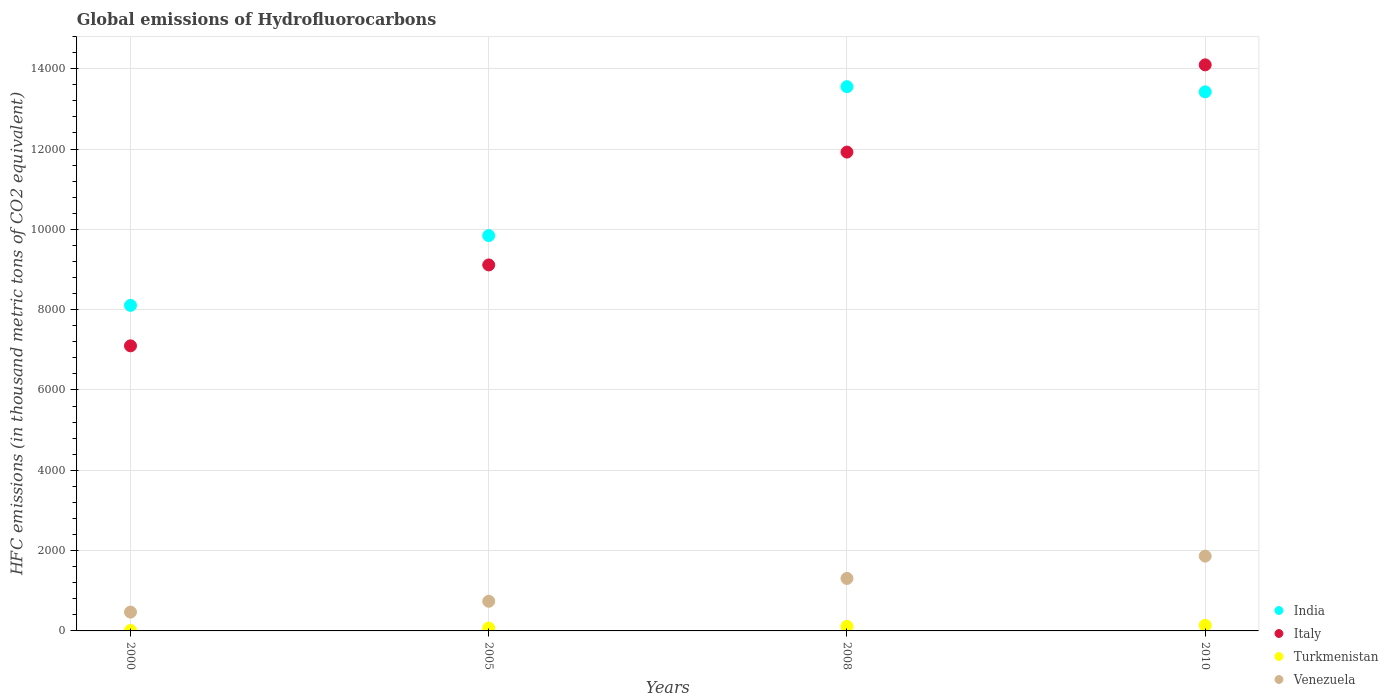How many different coloured dotlines are there?
Provide a short and direct response. 4. Is the number of dotlines equal to the number of legend labels?
Your response must be concise. Yes. What is the global emissions of Hydrofluorocarbons in Italy in 2005?
Offer a terse response. 9114.5. Across all years, what is the maximum global emissions of Hydrofluorocarbons in Turkmenistan?
Provide a short and direct response. 139. Across all years, what is the minimum global emissions of Hydrofluorocarbons in India?
Make the answer very short. 8107.2. What is the total global emissions of Hydrofluorocarbons in Turkmenistan in the graph?
Provide a succinct answer. 335. What is the difference between the global emissions of Hydrofluorocarbons in Venezuela in 2000 and that in 2008?
Offer a very short reply. -838.6. What is the difference between the global emissions of Hydrofluorocarbons in Italy in 2000 and the global emissions of Hydrofluorocarbons in Venezuela in 2008?
Provide a short and direct response. 5792.4. What is the average global emissions of Hydrofluorocarbons in Turkmenistan per year?
Your answer should be very brief. 83.75. In the year 2005, what is the difference between the global emissions of Hydrofluorocarbons in India and global emissions of Hydrofluorocarbons in Turkmenistan?
Offer a terse response. 9772.3. What is the ratio of the global emissions of Hydrofluorocarbons in Italy in 2005 to that in 2010?
Offer a very short reply. 0.65. Is the global emissions of Hydrofluorocarbons in Italy in 2005 less than that in 2010?
Your answer should be very brief. Yes. What is the difference between the highest and the second highest global emissions of Hydrofluorocarbons in Italy?
Give a very brief answer. 2172.5. What is the difference between the highest and the lowest global emissions of Hydrofluorocarbons in Venezuela?
Your response must be concise. 1394.5. Is it the case that in every year, the sum of the global emissions of Hydrofluorocarbons in Venezuela and global emissions of Hydrofluorocarbons in India  is greater than the sum of global emissions of Hydrofluorocarbons in Turkmenistan and global emissions of Hydrofluorocarbons in Italy?
Make the answer very short. Yes. Does the global emissions of Hydrofluorocarbons in Turkmenistan monotonically increase over the years?
Your response must be concise. Yes. How many dotlines are there?
Keep it short and to the point. 4. How many years are there in the graph?
Ensure brevity in your answer.  4. What is the difference between two consecutive major ticks on the Y-axis?
Offer a very short reply. 2000. Are the values on the major ticks of Y-axis written in scientific E-notation?
Keep it short and to the point. No. Does the graph contain any zero values?
Provide a succinct answer. No. Does the graph contain grids?
Your answer should be compact. Yes. How many legend labels are there?
Make the answer very short. 4. What is the title of the graph?
Give a very brief answer. Global emissions of Hydrofluorocarbons. What is the label or title of the X-axis?
Offer a very short reply. Years. What is the label or title of the Y-axis?
Give a very brief answer. HFC emissions (in thousand metric tons of CO2 equivalent). What is the HFC emissions (in thousand metric tons of CO2 equivalent) of India in 2000?
Offer a terse response. 8107.2. What is the HFC emissions (in thousand metric tons of CO2 equivalent) in Italy in 2000?
Provide a short and direct response. 7099.5. What is the HFC emissions (in thousand metric tons of CO2 equivalent) in Turkmenistan in 2000?
Make the answer very short. 10.9. What is the HFC emissions (in thousand metric tons of CO2 equivalent) of Venezuela in 2000?
Ensure brevity in your answer.  468.5. What is the HFC emissions (in thousand metric tons of CO2 equivalent) of India in 2005?
Offer a very short reply. 9845.2. What is the HFC emissions (in thousand metric tons of CO2 equivalent) of Italy in 2005?
Provide a succinct answer. 9114.5. What is the HFC emissions (in thousand metric tons of CO2 equivalent) of Turkmenistan in 2005?
Give a very brief answer. 72.9. What is the HFC emissions (in thousand metric tons of CO2 equivalent) in Venezuela in 2005?
Keep it short and to the point. 738.4. What is the HFC emissions (in thousand metric tons of CO2 equivalent) of India in 2008?
Provide a succinct answer. 1.36e+04. What is the HFC emissions (in thousand metric tons of CO2 equivalent) in Italy in 2008?
Keep it short and to the point. 1.19e+04. What is the HFC emissions (in thousand metric tons of CO2 equivalent) in Turkmenistan in 2008?
Give a very brief answer. 112.2. What is the HFC emissions (in thousand metric tons of CO2 equivalent) of Venezuela in 2008?
Your answer should be very brief. 1307.1. What is the HFC emissions (in thousand metric tons of CO2 equivalent) of India in 2010?
Your answer should be very brief. 1.34e+04. What is the HFC emissions (in thousand metric tons of CO2 equivalent) in Italy in 2010?
Make the answer very short. 1.41e+04. What is the HFC emissions (in thousand metric tons of CO2 equivalent) in Turkmenistan in 2010?
Ensure brevity in your answer.  139. What is the HFC emissions (in thousand metric tons of CO2 equivalent) of Venezuela in 2010?
Give a very brief answer. 1863. Across all years, what is the maximum HFC emissions (in thousand metric tons of CO2 equivalent) in India?
Ensure brevity in your answer.  1.36e+04. Across all years, what is the maximum HFC emissions (in thousand metric tons of CO2 equivalent) in Italy?
Provide a succinct answer. 1.41e+04. Across all years, what is the maximum HFC emissions (in thousand metric tons of CO2 equivalent) in Turkmenistan?
Ensure brevity in your answer.  139. Across all years, what is the maximum HFC emissions (in thousand metric tons of CO2 equivalent) of Venezuela?
Offer a terse response. 1863. Across all years, what is the minimum HFC emissions (in thousand metric tons of CO2 equivalent) of India?
Offer a terse response. 8107.2. Across all years, what is the minimum HFC emissions (in thousand metric tons of CO2 equivalent) in Italy?
Make the answer very short. 7099.5. Across all years, what is the minimum HFC emissions (in thousand metric tons of CO2 equivalent) of Turkmenistan?
Ensure brevity in your answer.  10.9. Across all years, what is the minimum HFC emissions (in thousand metric tons of CO2 equivalent) in Venezuela?
Your answer should be compact. 468.5. What is the total HFC emissions (in thousand metric tons of CO2 equivalent) of India in the graph?
Your answer should be very brief. 4.49e+04. What is the total HFC emissions (in thousand metric tons of CO2 equivalent) of Italy in the graph?
Offer a very short reply. 4.22e+04. What is the total HFC emissions (in thousand metric tons of CO2 equivalent) in Turkmenistan in the graph?
Give a very brief answer. 335. What is the total HFC emissions (in thousand metric tons of CO2 equivalent) in Venezuela in the graph?
Provide a succinct answer. 4377. What is the difference between the HFC emissions (in thousand metric tons of CO2 equivalent) of India in 2000 and that in 2005?
Offer a terse response. -1738. What is the difference between the HFC emissions (in thousand metric tons of CO2 equivalent) of Italy in 2000 and that in 2005?
Your answer should be compact. -2015. What is the difference between the HFC emissions (in thousand metric tons of CO2 equivalent) of Turkmenistan in 2000 and that in 2005?
Your answer should be compact. -62. What is the difference between the HFC emissions (in thousand metric tons of CO2 equivalent) in Venezuela in 2000 and that in 2005?
Make the answer very short. -269.9. What is the difference between the HFC emissions (in thousand metric tons of CO2 equivalent) in India in 2000 and that in 2008?
Provide a succinct answer. -5446.5. What is the difference between the HFC emissions (in thousand metric tons of CO2 equivalent) of Italy in 2000 and that in 2008?
Offer a very short reply. -4825. What is the difference between the HFC emissions (in thousand metric tons of CO2 equivalent) in Turkmenistan in 2000 and that in 2008?
Give a very brief answer. -101.3. What is the difference between the HFC emissions (in thousand metric tons of CO2 equivalent) in Venezuela in 2000 and that in 2008?
Offer a terse response. -838.6. What is the difference between the HFC emissions (in thousand metric tons of CO2 equivalent) in India in 2000 and that in 2010?
Provide a succinct answer. -5317.8. What is the difference between the HFC emissions (in thousand metric tons of CO2 equivalent) in Italy in 2000 and that in 2010?
Your answer should be compact. -6997.5. What is the difference between the HFC emissions (in thousand metric tons of CO2 equivalent) of Turkmenistan in 2000 and that in 2010?
Your answer should be compact. -128.1. What is the difference between the HFC emissions (in thousand metric tons of CO2 equivalent) in Venezuela in 2000 and that in 2010?
Provide a succinct answer. -1394.5. What is the difference between the HFC emissions (in thousand metric tons of CO2 equivalent) in India in 2005 and that in 2008?
Your response must be concise. -3708.5. What is the difference between the HFC emissions (in thousand metric tons of CO2 equivalent) in Italy in 2005 and that in 2008?
Offer a terse response. -2810. What is the difference between the HFC emissions (in thousand metric tons of CO2 equivalent) in Turkmenistan in 2005 and that in 2008?
Keep it short and to the point. -39.3. What is the difference between the HFC emissions (in thousand metric tons of CO2 equivalent) in Venezuela in 2005 and that in 2008?
Offer a terse response. -568.7. What is the difference between the HFC emissions (in thousand metric tons of CO2 equivalent) of India in 2005 and that in 2010?
Keep it short and to the point. -3579.8. What is the difference between the HFC emissions (in thousand metric tons of CO2 equivalent) in Italy in 2005 and that in 2010?
Provide a succinct answer. -4982.5. What is the difference between the HFC emissions (in thousand metric tons of CO2 equivalent) of Turkmenistan in 2005 and that in 2010?
Your answer should be compact. -66.1. What is the difference between the HFC emissions (in thousand metric tons of CO2 equivalent) of Venezuela in 2005 and that in 2010?
Provide a short and direct response. -1124.6. What is the difference between the HFC emissions (in thousand metric tons of CO2 equivalent) of India in 2008 and that in 2010?
Provide a succinct answer. 128.7. What is the difference between the HFC emissions (in thousand metric tons of CO2 equivalent) of Italy in 2008 and that in 2010?
Offer a very short reply. -2172.5. What is the difference between the HFC emissions (in thousand metric tons of CO2 equivalent) of Turkmenistan in 2008 and that in 2010?
Make the answer very short. -26.8. What is the difference between the HFC emissions (in thousand metric tons of CO2 equivalent) of Venezuela in 2008 and that in 2010?
Ensure brevity in your answer.  -555.9. What is the difference between the HFC emissions (in thousand metric tons of CO2 equivalent) of India in 2000 and the HFC emissions (in thousand metric tons of CO2 equivalent) of Italy in 2005?
Your answer should be compact. -1007.3. What is the difference between the HFC emissions (in thousand metric tons of CO2 equivalent) in India in 2000 and the HFC emissions (in thousand metric tons of CO2 equivalent) in Turkmenistan in 2005?
Make the answer very short. 8034.3. What is the difference between the HFC emissions (in thousand metric tons of CO2 equivalent) in India in 2000 and the HFC emissions (in thousand metric tons of CO2 equivalent) in Venezuela in 2005?
Keep it short and to the point. 7368.8. What is the difference between the HFC emissions (in thousand metric tons of CO2 equivalent) in Italy in 2000 and the HFC emissions (in thousand metric tons of CO2 equivalent) in Turkmenistan in 2005?
Offer a very short reply. 7026.6. What is the difference between the HFC emissions (in thousand metric tons of CO2 equivalent) in Italy in 2000 and the HFC emissions (in thousand metric tons of CO2 equivalent) in Venezuela in 2005?
Keep it short and to the point. 6361.1. What is the difference between the HFC emissions (in thousand metric tons of CO2 equivalent) in Turkmenistan in 2000 and the HFC emissions (in thousand metric tons of CO2 equivalent) in Venezuela in 2005?
Provide a succinct answer. -727.5. What is the difference between the HFC emissions (in thousand metric tons of CO2 equivalent) of India in 2000 and the HFC emissions (in thousand metric tons of CO2 equivalent) of Italy in 2008?
Your answer should be compact. -3817.3. What is the difference between the HFC emissions (in thousand metric tons of CO2 equivalent) of India in 2000 and the HFC emissions (in thousand metric tons of CO2 equivalent) of Turkmenistan in 2008?
Ensure brevity in your answer.  7995. What is the difference between the HFC emissions (in thousand metric tons of CO2 equivalent) in India in 2000 and the HFC emissions (in thousand metric tons of CO2 equivalent) in Venezuela in 2008?
Provide a succinct answer. 6800.1. What is the difference between the HFC emissions (in thousand metric tons of CO2 equivalent) in Italy in 2000 and the HFC emissions (in thousand metric tons of CO2 equivalent) in Turkmenistan in 2008?
Provide a short and direct response. 6987.3. What is the difference between the HFC emissions (in thousand metric tons of CO2 equivalent) in Italy in 2000 and the HFC emissions (in thousand metric tons of CO2 equivalent) in Venezuela in 2008?
Your response must be concise. 5792.4. What is the difference between the HFC emissions (in thousand metric tons of CO2 equivalent) of Turkmenistan in 2000 and the HFC emissions (in thousand metric tons of CO2 equivalent) of Venezuela in 2008?
Keep it short and to the point. -1296.2. What is the difference between the HFC emissions (in thousand metric tons of CO2 equivalent) in India in 2000 and the HFC emissions (in thousand metric tons of CO2 equivalent) in Italy in 2010?
Offer a terse response. -5989.8. What is the difference between the HFC emissions (in thousand metric tons of CO2 equivalent) in India in 2000 and the HFC emissions (in thousand metric tons of CO2 equivalent) in Turkmenistan in 2010?
Your response must be concise. 7968.2. What is the difference between the HFC emissions (in thousand metric tons of CO2 equivalent) in India in 2000 and the HFC emissions (in thousand metric tons of CO2 equivalent) in Venezuela in 2010?
Give a very brief answer. 6244.2. What is the difference between the HFC emissions (in thousand metric tons of CO2 equivalent) of Italy in 2000 and the HFC emissions (in thousand metric tons of CO2 equivalent) of Turkmenistan in 2010?
Offer a terse response. 6960.5. What is the difference between the HFC emissions (in thousand metric tons of CO2 equivalent) of Italy in 2000 and the HFC emissions (in thousand metric tons of CO2 equivalent) of Venezuela in 2010?
Your answer should be compact. 5236.5. What is the difference between the HFC emissions (in thousand metric tons of CO2 equivalent) in Turkmenistan in 2000 and the HFC emissions (in thousand metric tons of CO2 equivalent) in Venezuela in 2010?
Offer a very short reply. -1852.1. What is the difference between the HFC emissions (in thousand metric tons of CO2 equivalent) in India in 2005 and the HFC emissions (in thousand metric tons of CO2 equivalent) in Italy in 2008?
Your answer should be very brief. -2079.3. What is the difference between the HFC emissions (in thousand metric tons of CO2 equivalent) of India in 2005 and the HFC emissions (in thousand metric tons of CO2 equivalent) of Turkmenistan in 2008?
Make the answer very short. 9733. What is the difference between the HFC emissions (in thousand metric tons of CO2 equivalent) in India in 2005 and the HFC emissions (in thousand metric tons of CO2 equivalent) in Venezuela in 2008?
Offer a very short reply. 8538.1. What is the difference between the HFC emissions (in thousand metric tons of CO2 equivalent) of Italy in 2005 and the HFC emissions (in thousand metric tons of CO2 equivalent) of Turkmenistan in 2008?
Give a very brief answer. 9002.3. What is the difference between the HFC emissions (in thousand metric tons of CO2 equivalent) in Italy in 2005 and the HFC emissions (in thousand metric tons of CO2 equivalent) in Venezuela in 2008?
Your answer should be very brief. 7807.4. What is the difference between the HFC emissions (in thousand metric tons of CO2 equivalent) of Turkmenistan in 2005 and the HFC emissions (in thousand metric tons of CO2 equivalent) of Venezuela in 2008?
Ensure brevity in your answer.  -1234.2. What is the difference between the HFC emissions (in thousand metric tons of CO2 equivalent) in India in 2005 and the HFC emissions (in thousand metric tons of CO2 equivalent) in Italy in 2010?
Keep it short and to the point. -4251.8. What is the difference between the HFC emissions (in thousand metric tons of CO2 equivalent) in India in 2005 and the HFC emissions (in thousand metric tons of CO2 equivalent) in Turkmenistan in 2010?
Ensure brevity in your answer.  9706.2. What is the difference between the HFC emissions (in thousand metric tons of CO2 equivalent) of India in 2005 and the HFC emissions (in thousand metric tons of CO2 equivalent) of Venezuela in 2010?
Ensure brevity in your answer.  7982.2. What is the difference between the HFC emissions (in thousand metric tons of CO2 equivalent) of Italy in 2005 and the HFC emissions (in thousand metric tons of CO2 equivalent) of Turkmenistan in 2010?
Give a very brief answer. 8975.5. What is the difference between the HFC emissions (in thousand metric tons of CO2 equivalent) of Italy in 2005 and the HFC emissions (in thousand metric tons of CO2 equivalent) of Venezuela in 2010?
Offer a very short reply. 7251.5. What is the difference between the HFC emissions (in thousand metric tons of CO2 equivalent) of Turkmenistan in 2005 and the HFC emissions (in thousand metric tons of CO2 equivalent) of Venezuela in 2010?
Make the answer very short. -1790.1. What is the difference between the HFC emissions (in thousand metric tons of CO2 equivalent) in India in 2008 and the HFC emissions (in thousand metric tons of CO2 equivalent) in Italy in 2010?
Your answer should be very brief. -543.3. What is the difference between the HFC emissions (in thousand metric tons of CO2 equivalent) in India in 2008 and the HFC emissions (in thousand metric tons of CO2 equivalent) in Turkmenistan in 2010?
Your response must be concise. 1.34e+04. What is the difference between the HFC emissions (in thousand metric tons of CO2 equivalent) of India in 2008 and the HFC emissions (in thousand metric tons of CO2 equivalent) of Venezuela in 2010?
Your answer should be compact. 1.17e+04. What is the difference between the HFC emissions (in thousand metric tons of CO2 equivalent) of Italy in 2008 and the HFC emissions (in thousand metric tons of CO2 equivalent) of Turkmenistan in 2010?
Your answer should be very brief. 1.18e+04. What is the difference between the HFC emissions (in thousand metric tons of CO2 equivalent) in Italy in 2008 and the HFC emissions (in thousand metric tons of CO2 equivalent) in Venezuela in 2010?
Offer a terse response. 1.01e+04. What is the difference between the HFC emissions (in thousand metric tons of CO2 equivalent) in Turkmenistan in 2008 and the HFC emissions (in thousand metric tons of CO2 equivalent) in Venezuela in 2010?
Provide a short and direct response. -1750.8. What is the average HFC emissions (in thousand metric tons of CO2 equivalent) in India per year?
Give a very brief answer. 1.12e+04. What is the average HFC emissions (in thousand metric tons of CO2 equivalent) of Italy per year?
Keep it short and to the point. 1.06e+04. What is the average HFC emissions (in thousand metric tons of CO2 equivalent) in Turkmenistan per year?
Your answer should be very brief. 83.75. What is the average HFC emissions (in thousand metric tons of CO2 equivalent) in Venezuela per year?
Provide a short and direct response. 1094.25. In the year 2000, what is the difference between the HFC emissions (in thousand metric tons of CO2 equivalent) of India and HFC emissions (in thousand metric tons of CO2 equivalent) of Italy?
Ensure brevity in your answer.  1007.7. In the year 2000, what is the difference between the HFC emissions (in thousand metric tons of CO2 equivalent) of India and HFC emissions (in thousand metric tons of CO2 equivalent) of Turkmenistan?
Ensure brevity in your answer.  8096.3. In the year 2000, what is the difference between the HFC emissions (in thousand metric tons of CO2 equivalent) of India and HFC emissions (in thousand metric tons of CO2 equivalent) of Venezuela?
Keep it short and to the point. 7638.7. In the year 2000, what is the difference between the HFC emissions (in thousand metric tons of CO2 equivalent) of Italy and HFC emissions (in thousand metric tons of CO2 equivalent) of Turkmenistan?
Your response must be concise. 7088.6. In the year 2000, what is the difference between the HFC emissions (in thousand metric tons of CO2 equivalent) in Italy and HFC emissions (in thousand metric tons of CO2 equivalent) in Venezuela?
Your response must be concise. 6631. In the year 2000, what is the difference between the HFC emissions (in thousand metric tons of CO2 equivalent) of Turkmenistan and HFC emissions (in thousand metric tons of CO2 equivalent) of Venezuela?
Your response must be concise. -457.6. In the year 2005, what is the difference between the HFC emissions (in thousand metric tons of CO2 equivalent) of India and HFC emissions (in thousand metric tons of CO2 equivalent) of Italy?
Your answer should be very brief. 730.7. In the year 2005, what is the difference between the HFC emissions (in thousand metric tons of CO2 equivalent) in India and HFC emissions (in thousand metric tons of CO2 equivalent) in Turkmenistan?
Your response must be concise. 9772.3. In the year 2005, what is the difference between the HFC emissions (in thousand metric tons of CO2 equivalent) of India and HFC emissions (in thousand metric tons of CO2 equivalent) of Venezuela?
Provide a short and direct response. 9106.8. In the year 2005, what is the difference between the HFC emissions (in thousand metric tons of CO2 equivalent) of Italy and HFC emissions (in thousand metric tons of CO2 equivalent) of Turkmenistan?
Your response must be concise. 9041.6. In the year 2005, what is the difference between the HFC emissions (in thousand metric tons of CO2 equivalent) in Italy and HFC emissions (in thousand metric tons of CO2 equivalent) in Venezuela?
Your answer should be compact. 8376.1. In the year 2005, what is the difference between the HFC emissions (in thousand metric tons of CO2 equivalent) in Turkmenistan and HFC emissions (in thousand metric tons of CO2 equivalent) in Venezuela?
Your response must be concise. -665.5. In the year 2008, what is the difference between the HFC emissions (in thousand metric tons of CO2 equivalent) in India and HFC emissions (in thousand metric tons of CO2 equivalent) in Italy?
Ensure brevity in your answer.  1629.2. In the year 2008, what is the difference between the HFC emissions (in thousand metric tons of CO2 equivalent) of India and HFC emissions (in thousand metric tons of CO2 equivalent) of Turkmenistan?
Make the answer very short. 1.34e+04. In the year 2008, what is the difference between the HFC emissions (in thousand metric tons of CO2 equivalent) of India and HFC emissions (in thousand metric tons of CO2 equivalent) of Venezuela?
Your response must be concise. 1.22e+04. In the year 2008, what is the difference between the HFC emissions (in thousand metric tons of CO2 equivalent) in Italy and HFC emissions (in thousand metric tons of CO2 equivalent) in Turkmenistan?
Your answer should be very brief. 1.18e+04. In the year 2008, what is the difference between the HFC emissions (in thousand metric tons of CO2 equivalent) of Italy and HFC emissions (in thousand metric tons of CO2 equivalent) of Venezuela?
Your answer should be compact. 1.06e+04. In the year 2008, what is the difference between the HFC emissions (in thousand metric tons of CO2 equivalent) of Turkmenistan and HFC emissions (in thousand metric tons of CO2 equivalent) of Venezuela?
Offer a terse response. -1194.9. In the year 2010, what is the difference between the HFC emissions (in thousand metric tons of CO2 equivalent) in India and HFC emissions (in thousand metric tons of CO2 equivalent) in Italy?
Your answer should be compact. -672. In the year 2010, what is the difference between the HFC emissions (in thousand metric tons of CO2 equivalent) in India and HFC emissions (in thousand metric tons of CO2 equivalent) in Turkmenistan?
Your answer should be very brief. 1.33e+04. In the year 2010, what is the difference between the HFC emissions (in thousand metric tons of CO2 equivalent) in India and HFC emissions (in thousand metric tons of CO2 equivalent) in Venezuela?
Your response must be concise. 1.16e+04. In the year 2010, what is the difference between the HFC emissions (in thousand metric tons of CO2 equivalent) in Italy and HFC emissions (in thousand metric tons of CO2 equivalent) in Turkmenistan?
Provide a short and direct response. 1.40e+04. In the year 2010, what is the difference between the HFC emissions (in thousand metric tons of CO2 equivalent) in Italy and HFC emissions (in thousand metric tons of CO2 equivalent) in Venezuela?
Offer a terse response. 1.22e+04. In the year 2010, what is the difference between the HFC emissions (in thousand metric tons of CO2 equivalent) in Turkmenistan and HFC emissions (in thousand metric tons of CO2 equivalent) in Venezuela?
Give a very brief answer. -1724. What is the ratio of the HFC emissions (in thousand metric tons of CO2 equivalent) in India in 2000 to that in 2005?
Make the answer very short. 0.82. What is the ratio of the HFC emissions (in thousand metric tons of CO2 equivalent) in Italy in 2000 to that in 2005?
Give a very brief answer. 0.78. What is the ratio of the HFC emissions (in thousand metric tons of CO2 equivalent) in Turkmenistan in 2000 to that in 2005?
Keep it short and to the point. 0.15. What is the ratio of the HFC emissions (in thousand metric tons of CO2 equivalent) of Venezuela in 2000 to that in 2005?
Your response must be concise. 0.63. What is the ratio of the HFC emissions (in thousand metric tons of CO2 equivalent) of India in 2000 to that in 2008?
Offer a very short reply. 0.6. What is the ratio of the HFC emissions (in thousand metric tons of CO2 equivalent) of Italy in 2000 to that in 2008?
Provide a succinct answer. 0.6. What is the ratio of the HFC emissions (in thousand metric tons of CO2 equivalent) of Turkmenistan in 2000 to that in 2008?
Provide a short and direct response. 0.1. What is the ratio of the HFC emissions (in thousand metric tons of CO2 equivalent) of Venezuela in 2000 to that in 2008?
Ensure brevity in your answer.  0.36. What is the ratio of the HFC emissions (in thousand metric tons of CO2 equivalent) of India in 2000 to that in 2010?
Give a very brief answer. 0.6. What is the ratio of the HFC emissions (in thousand metric tons of CO2 equivalent) of Italy in 2000 to that in 2010?
Your answer should be very brief. 0.5. What is the ratio of the HFC emissions (in thousand metric tons of CO2 equivalent) in Turkmenistan in 2000 to that in 2010?
Keep it short and to the point. 0.08. What is the ratio of the HFC emissions (in thousand metric tons of CO2 equivalent) of Venezuela in 2000 to that in 2010?
Ensure brevity in your answer.  0.25. What is the ratio of the HFC emissions (in thousand metric tons of CO2 equivalent) in India in 2005 to that in 2008?
Your answer should be very brief. 0.73. What is the ratio of the HFC emissions (in thousand metric tons of CO2 equivalent) of Italy in 2005 to that in 2008?
Offer a very short reply. 0.76. What is the ratio of the HFC emissions (in thousand metric tons of CO2 equivalent) in Turkmenistan in 2005 to that in 2008?
Ensure brevity in your answer.  0.65. What is the ratio of the HFC emissions (in thousand metric tons of CO2 equivalent) in Venezuela in 2005 to that in 2008?
Your answer should be very brief. 0.56. What is the ratio of the HFC emissions (in thousand metric tons of CO2 equivalent) of India in 2005 to that in 2010?
Give a very brief answer. 0.73. What is the ratio of the HFC emissions (in thousand metric tons of CO2 equivalent) in Italy in 2005 to that in 2010?
Ensure brevity in your answer.  0.65. What is the ratio of the HFC emissions (in thousand metric tons of CO2 equivalent) of Turkmenistan in 2005 to that in 2010?
Ensure brevity in your answer.  0.52. What is the ratio of the HFC emissions (in thousand metric tons of CO2 equivalent) of Venezuela in 2005 to that in 2010?
Your answer should be compact. 0.4. What is the ratio of the HFC emissions (in thousand metric tons of CO2 equivalent) of India in 2008 to that in 2010?
Make the answer very short. 1.01. What is the ratio of the HFC emissions (in thousand metric tons of CO2 equivalent) in Italy in 2008 to that in 2010?
Offer a terse response. 0.85. What is the ratio of the HFC emissions (in thousand metric tons of CO2 equivalent) of Turkmenistan in 2008 to that in 2010?
Your response must be concise. 0.81. What is the ratio of the HFC emissions (in thousand metric tons of CO2 equivalent) of Venezuela in 2008 to that in 2010?
Provide a short and direct response. 0.7. What is the difference between the highest and the second highest HFC emissions (in thousand metric tons of CO2 equivalent) of India?
Keep it short and to the point. 128.7. What is the difference between the highest and the second highest HFC emissions (in thousand metric tons of CO2 equivalent) in Italy?
Provide a succinct answer. 2172.5. What is the difference between the highest and the second highest HFC emissions (in thousand metric tons of CO2 equivalent) of Turkmenistan?
Make the answer very short. 26.8. What is the difference between the highest and the second highest HFC emissions (in thousand metric tons of CO2 equivalent) in Venezuela?
Provide a succinct answer. 555.9. What is the difference between the highest and the lowest HFC emissions (in thousand metric tons of CO2 equivalent) in India?
Offer a terse response. 5446.5. What is the difference between the highest and the lowest HFC emissions (in thousand metric tons of CO2 equivalent) of Italy?
Offer a very short reply. 6997.5. What is the difference between the highest and the lowest HFC emissions (in thousand metric tons of CO2 equivalent) in Turkmenistan?
Give a very brief answer. 128.1. What is the difference between the highest and the lowest HFC emissions (in thousand metric tons of CO2 equivalent) in Venezuela?
Your response must be concise. 1394.5. 